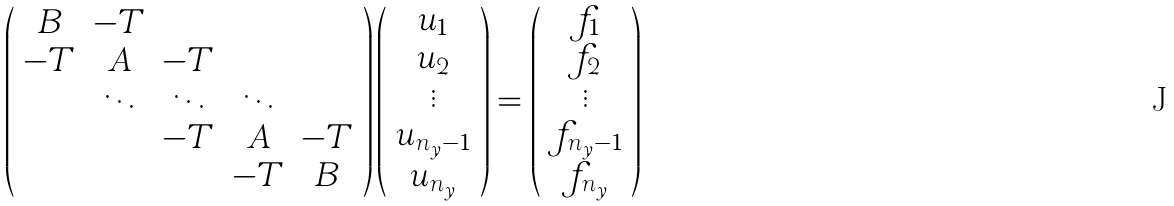<formula> <loc_0><loc_0><loc_500><loc_500>\left ( \begin{array} { c c c c c } B & - T & & & \\ - T & A & - T & & \\ & \ddots & \ddots & \ddots & \\ & & - T & A & - T \\ & & & - T & B \end{array} \right ) \left ( \begin{array} { c } u _ { 1 } \\ u _ { 2 } \\ \vdots \\ u _ { n _ { y } - 1 } \\ u _ { n _ { y } } \end{array} \right ) = \left ( \begin{array} { c } f _ { 1 } \\ f _ { 2 } \\ \vdots \\ f _ { n _ { y } - 1 } \\ f _ { n _ { y } } \end{array} \right )</formula> 